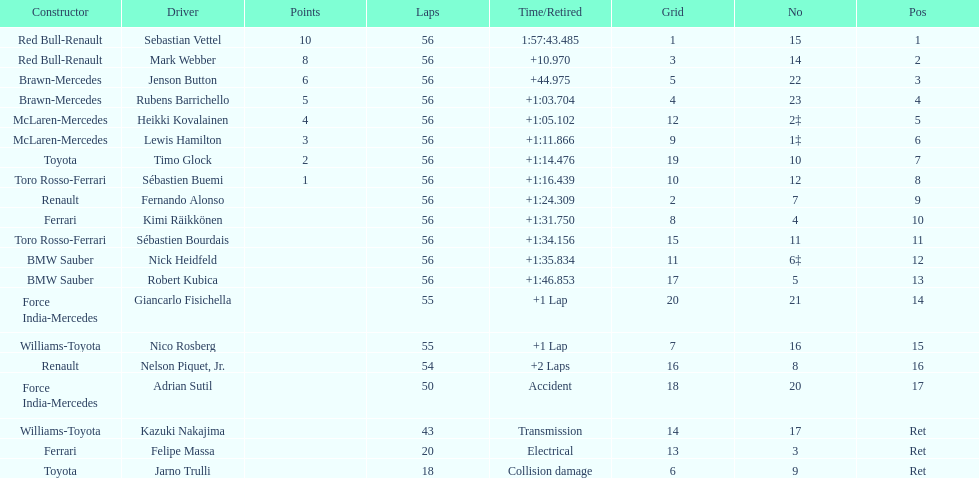How many laps in total is the race? 56. 